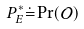<formula> <loc_0><loc_0><loc_500><loc_500>P ^ { * } _ { E } \dot { = } \Pr ( \mathcal { O } )</formula> 